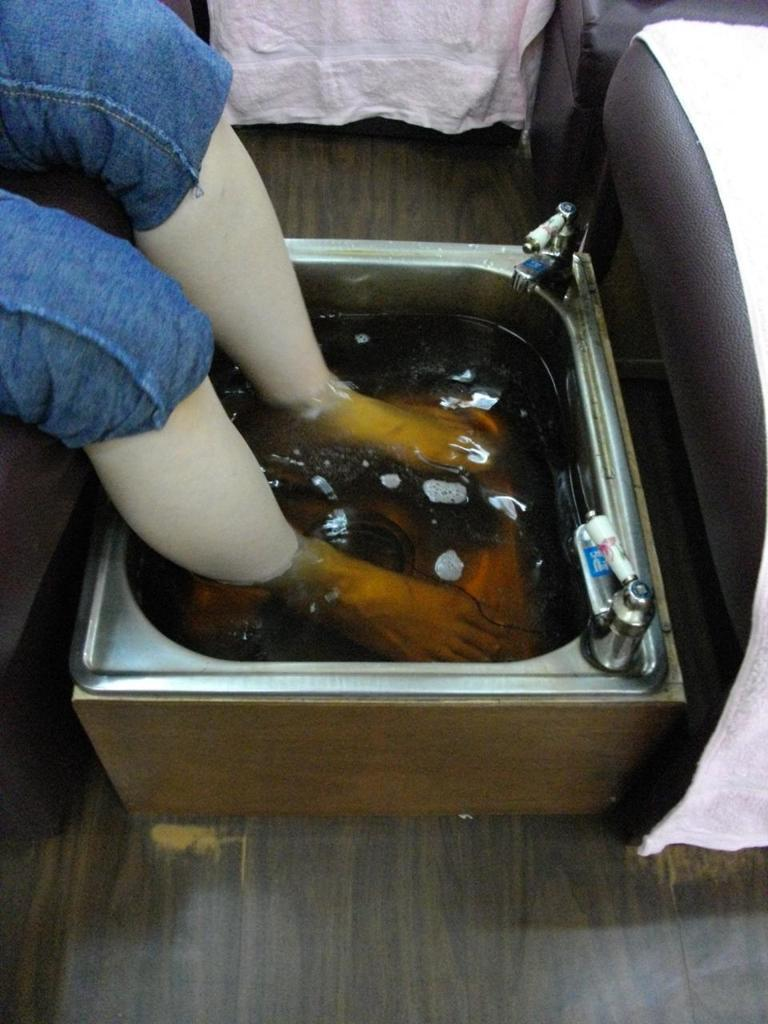What is the main subject of the image? The main subject of the image is persons' legs in some liquid. What type of flooring is visible at the bottom of the image? There is wooden flooring at the bottom of the image. What furniture can be seen to the right side of the image? There is a chair with a cloth on it to the right side of the image. What type of payment is being made in the image? There is no payment being made in the image; it features persons' legs in some liquid, wooden flooring, and a chair with a cloth on it. What joke is being told by the person with their legs in the liquid? There is no person with their legs in the liquid telling a joke in the image; it only shows their legs in the liquid, wooden flooring, and a chair with a cloth on it. 